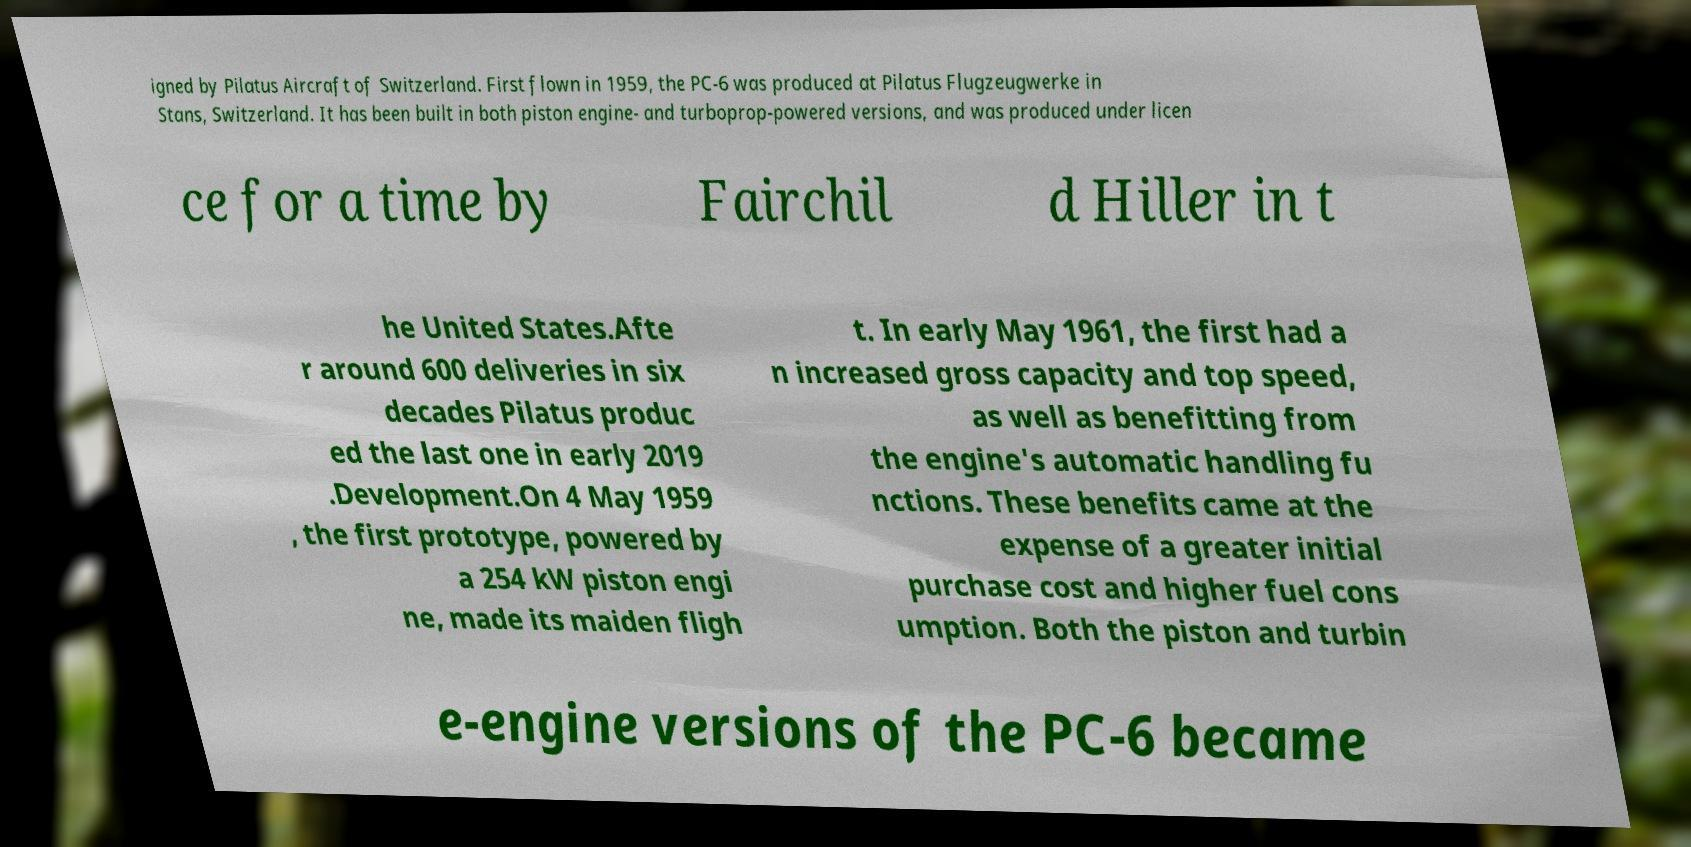There's text embedded in this image that I need extracted. Can you transcribe it verbatim? igned by Pilatus Aircraft of Switzerland. First flown in 1959, the PC-6 was produced at Pilatus Flugzeugwerke in Stans, Switzerland. It has been built in both piston engine- and turboprop-powered versions, and was produced under licen ce for a time by Fairchil d Hiller in t he United States.Afte r around 600 deliveries in six decades Pilatus produc ed the last one in early 2019 .Development.On 4 May 1959 , the first prototype, powered by a 254 kW piston engi ne, made its maiden fligh t. In early May 1961, the first had a n increased gross capacity and top speed, as well as benefitting from the engine's automatic handling fu nctions. These benefits came at the expense of a greater initial purchase cost and higher fuel cons umption. Both the piston and turbin e-engine versions of the PC-6 became 